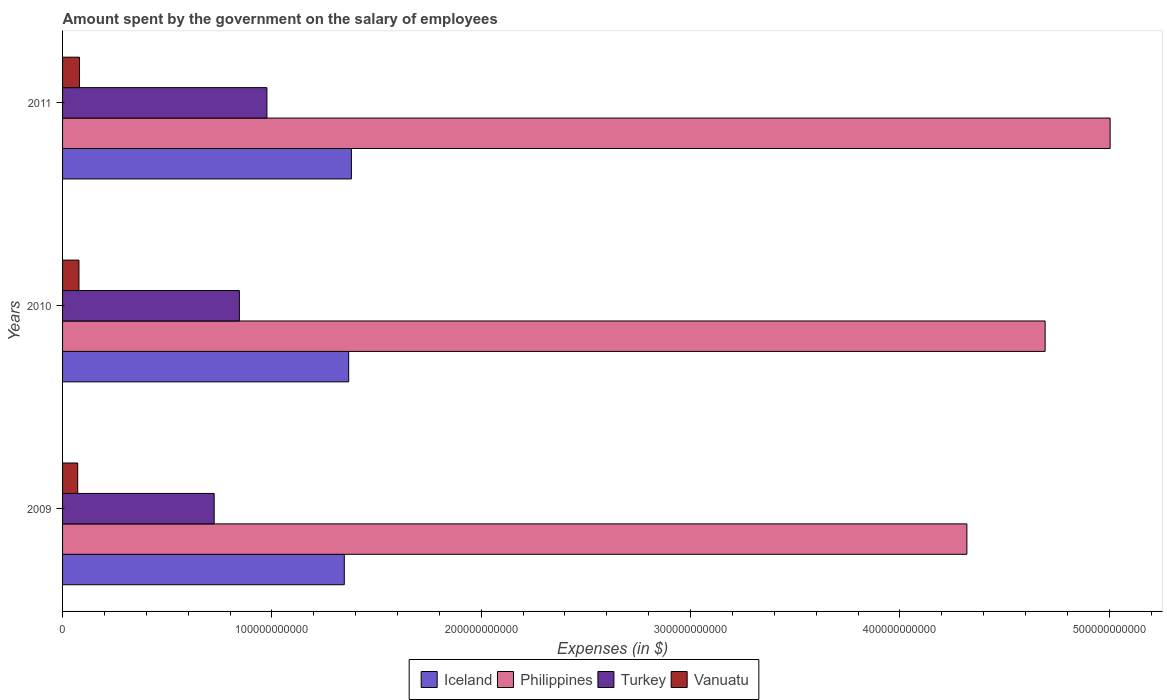How many different coloured bars are there?
Give a very brief answer. 4. Are the number of bars per tick equal to the number of legend labels?
Make the answer very short. Yes. Are the number of bars on each tick of the Y-axis equal?
Keep it short and to the point. Yes. How many bars are there on the 1st tick from the bottom?
Ensure brevity in your answer.  4. What is the amount spent on the salary of employees by the government in Turkey in 2009?
Your response must be concise. 7.24e+1. Across all years, what is the maximum amount spent on the salary of employees by the government in Vanuatu?
Offer a terse response. 8.09e+09. Across all years, what is the minimum amount spent on the salary of employees by the government in Iceland?
Ensure brevity in your answer.  1.35e+11. In which year was the amount spent on the salary of employees by the government in Vanuatu maximum?
Keep it short and to the point. 2011. In which year was the amount spent on the salary of employees by the government in Iceland minimum?
Your response must be concise. 2009. What is the total amount spent on the salary of employees by the government in Vanuatu in the graph?
Give a very brief answer. 2.32e+1. What is the difference between the amount spent on the salary of employees by the government in Turkey in 2010 and that in 2011?
Keep it short and to the point. -1.32e+1. What is the difference between the amount spent on the salary of employees by the government in Turkey in 2010 and the amount spent on the salary of employees by the government in Iceland in 2011?
Offer a terse response. -5.35e+1. What is the average amount spent on the salary of employees by the government in Iceland per year?
Keep it short and to the point. 1.36e+11. In the year 2010, what is the difference between the amount spent on the salary of employees by the government in Turkey and amount spent on the salary of employees by the government in Iceland?
Make the answer very short. -5.22e+1. What is the ratio of the amount spent on the salary of employees by the government in Turkey in 2009 to that in 2011?
Your response must be concise. 0.74. Is the amount spent on the salary of employees by the government in Turkey in 2009 less than that in 2010?
Keep it short and to the point. Yes. What is the difference between the highest and the second highest amount spent on the salary of employees by the government in Philippines?
Ensure brevity in your answer.  3.10e+1. What is the difference between the highest and the lowest amount spent on the salary of employees by the government in Iceland?
Provide a short and direct response. 3.39e+09. Is the sum of the amount spent on the salary of employees by the government in Turkey in 2009 and 2010 greater than the maximum amount spent on the salary of employees by the government in Iceland across all years?
Your answer should be compact. Yes. Is it the case that in every year, the sum of the amount spent on the salary of employees by the government in Vanuatu and amount spent on the salary of employees by the government in Turkey is greater than the sum of amount spent on the salary of employees by the government in Philippines and amount spent on the salary of employees by the government in Iceland?
Your response must be concise. No. What does the 4th bar from the bottom in 2010 represents?
Your response must be concise. Vanuatu. Is it the case that in every year, the sum of the amount spent on the salary of employees by the government in Iceland and amount spent on the salary of employees by the government in Vanuatu is greater than the amount spent on the salary of employees by the government in Turkey?
Offer a terse response. Yes. How many bars are there?
Provide a succinct answer. 12. Are all the bars in the graph horizontal?
Offer a very short reply. Yes. What is the difference between two consecutive major ticks on the X-axis?
Your answer should be very brief. 1.00e+11. Are the values on the major ticks of X-axis written in scientific E-notation?
Your answer should be compact. No. Does the graph contain any zero values?
Make the answer very short. No. Where does the legend appear in the graph?
Your answer should be compact. Bottom center. How many legend labels are there?
Your response must be concise. 4. How are the legend labels stacked?
Your answer should be very brief. Horizontal. What is the title of the graph?
Your response must be concise. Amount spent by the government on the salary of employees. Does "Namibia" appear as one of the legend labels in the graph?
Your response must be concise. No. What is the label or title of the X-axis?
Your answer should be very brief. Expenses (in $). What is the label or title of the Y-axis?
Offer a terse response. Years. What is the Expenses (in $) of Iceland in 2009?
Provide a succinct answer. 1.35e+11. What is the Expenses (in $) of Philippines in 2009?
Provide a short and direct response. 4.32e+11. What is the Expenses (in $) in Turkey in 2009?
Make the answer very short. 7.24e+1. What is the Expenses (in $) of Vanuatu in 2009?
Provide a short and direct response. 7.24e+09. What is the Expenses (in $) of Iceland in 2010?
Provide a succinct answer. 1.37e+11. What is the Expenses (in $) in Philippines in 2010?
Ensure brevity in your answer.  4.69e+11. What is the Expenses (in $) in Turkey in 2010?
Make the answer very short. 8.45e+1. What is the Expenses (in $) in Vanuatu in 2010?
Your answer should be compact. 7.83e+09. What is the Expenses (in $) of Iceland in 2011?
Provide a succinct answer. 1.38e+11. What is the Expenses (in $) of Philippines in 2011?
Provide a succinct answer. 5.00e+11. What is the Expenses (in $) in Turkey in 2011?
Provide a short and direct response. 9.76e+1. What is the Expenses (in $) of Vanuatu in 2011?
Provide a short and direct response. 8.09e+09. Across all years, what is the maximum Expenses (in $) of Iceland?
Offer a terse response. 1.38e+11. Across all years, what is the maximum Expenses (in $) of Philippines?
Provide a succinct answer. 5.00e+11. Across all years, what is the maximum Expenses (in $) of Turkey?
Ensure brevity in your answer.  9.76e+1. Across all years, what is the maximum Expenses (in $) in Vanuatu?
Your answer should be very brief. 8.09e+09. Across all years, what is the minimum Expenses (in $) in Iceland?
Provide a succinct answer. 1.35e+11. Across all years, what is the minimum Expenses (in $) of Philippines?
Your answer should be very brief. 4.32e+11. Across all years, what is the minimum Expenses (in $) of Turkey?
Ensure brevity in your answer.  7.24e+1. Across all years, what is the minimum Expenses (in $) in Vanuatu?
Your response must be concise. 7.24e+09. What is the total Expenses (in $) in Iceland in the graph?
Your response must be concise. 4.09e+11. What is the total Expenses (in $) of Philippines in the graph?
Your answer should be very brief. 1.40e+12. What is the total Expenses (in $) of Turkey in the graph?
Give a very brief answer. 2.55e+11. What is the total Expenses (in $) of Vanuatu in the graph?
Offer a very short reply. 2.32e+1. What is the difference between the Expenses (in $) of Iceland in 2009 and that in 2010?
Your answer should be very brief. -2.09e+09. What is the difference between the Expenses (in $) of Philippines in 2009 and that in 2010?
Offer a very short reply. -3.74e+1. What is the difference between the Expenses (in $) of Turkey in 2009 and that in 2010?
Your answer should be very brief. -1.20e+1. What is the difference between the Expenses (in $) in Vanuatu in 2009 and that in 2010?
Your answer should be compact. -5.95e+08. What is the difference between the Expenses (in $) in Iceland in 2009 and that in 2011?
Your response must be concise. -3.39e+09. What is the difference between the Expenses (in $) of Philippines in 2009 and that in 2011?
Your answer should be compact. -6.84e+1. What is the difference between the Expenses (in $) in Turkey in 2009 and that in 2011?
Keep it short and to the point. -2.52e+1. What is the difference between the Expenses (in $) of Vanuatu in 2009 and that in 2011?
Ensure brevity in your answer.  -8.52e+08. What is the difference between the Expenses (in $) in Iceland in 2010 and that in 2011?
Provide a short and direct response. -1.29e+09. What is the difference between the Expenses (in $) of Philippines in 2010 and that in 2011?
Your answer should be very brief. -3.10e+1. What is the difference between the Expenses (in $) of Turkey in 2010 and that in 2011?
Your answer should be very brief. -1.32e+1. What is the difference between the Expenses (in $) of Vanuatu in 2010 and that in 2011?
Provide a succinct answer. -2.57e+08. What is the difference between the Expenses (in $) in Iceland in 2009 and the Expenses (in $) in Philippines in 2010?
Offer a terse response. -3.35e+11. What is the difference between the Expenses (in $) of Iceland in 2009 and the Expenses (in $) of Turkey in 2010?
Your response must be concise. 5.01e+1. What is the difference between the Expenses (in $) of Iceland in 2009 and the Expenses (in $) of Vanuatu in 2010?
Your answer should be compact. 1.27e+11. What is the difference between the Expenses (in $) of Philippines in 2009 and the Expenses (in $) of Turkey in 2010?
Provide a short and direct response. 3.48e+11. What is the difference between the Expenses (in $) in Philippines in 2009 and the Expenses (in $) in Vanuatu in 2010?
Offer a very short reply. 4.24e+11. What is the difference between the Expenses (in $) in Turkey in 2009 and the Expenses (in $) in Vanuatu in 2010?
Provide a succinct answer. 6.46e+1. What is the difference between the Expenses (in $) in Iceland in 2009 and the Expenses (in $) in Philippines in 2011?
Offer a terse response. -3.66e+11. What is the difference between the Expenses (in $) in Iceland in 2009 and the Expenses (in $) in Turkey in 2011?
Your response must be concise. 3.70e+1. What is the difference between the Expenses (in $) in Iceland in 2009 and the Expenses (in $) in Vanuatu in 2011?
Your answer should be compact. 1.27e+11. What is the difference between the Expenses (in $) in Philippines in 2009 and the Expenses (in $) in Turkey in 2011?
Your answer should be compact. 3.34e+11. What is the difference between the Expenses (in $) of Philippines in 2009 and the Expenses (in $) of Vanuatu in 2011?
Offer a terse response. 4.24e+11. What is the difference between the Expenses (in $) of Turkey in 2009 and the Expenses (in $) of Vanuatu in 2011?
Your answer should be very brief. 6.43e+1. What is the difference between the Expenses (in $) of Iceland in 2010 and the Expenses (in $) of Philippines in 2011?
Your answer should be compact. -3.64e+11. What is the difference between the Expenses (in $) of Iceland in 2010 and the Expenses (in $) of Turkey in 2011?
Your answer should be very brief. 3.91e+1. What is the difference between the Expenses (in $) of Iceland in 2010 and the Expenses (in $) of Vanuatu in 2011?
Make the answer very short. 1.29e+11. What is the difference between the Expenses (in $) of Philippines in 2010 and the Expenses (in $) of Turkey in 2011?
Keep it short and to the point. 3.72e+11. What is the difference between the Expenses (in $) in Philippines in 2010 and the Expenses (in $) in Vanuatu in 2011?
Ensure brevity in your answer.  4.61e+11. What is the difference between the Expenses (in $) in Turkey in 2010 and the Expenses (in $) in Vanuatu in 2011?
Your response must be concise. 7.64e+1. What is the average Expenses (in $) of Iceland per year?
Your answer should be very brief. 1.36e+11. What is the average Expenses (in $) in Philippines per year?
Your answer should be compact. 4.67e+11. What is the average Expenses (in $) of Turkey per year?
Your response must be concise. 8.48e+1. What is the average Expenses (in $) of Vanuatu per year?
Give a very brief answer. 7.72e+09. In the year 2009, what is the difference between the Expenses (in $) of Iceland and Expenses (in $) of Philippines?
Your answer should be compact. -2.97e+11. In the year 2009, what is the difference between the Expenses (in $) in Iceland and Expenses (in $) in Turkey?
Make the answer very short. 6.22e+1. In the year 2009, what is the difference between the Expenses (in $) in Iceland and Expenses (in $) in Vanuatu?
Offer a terse response. 1.27e+11. In the year 2009, what is the difference between the Expenses (in $) of Philippines and Expenses (in $) of Turkey?
Your answer should be very brief. 3.60e+11. In the year 2009, what is the difference between the Expenses (in $) in Philippines and Expenses (in $) in Vanuatu?
Your answer should be compact. 4.25e+11. In the year 2009, what is the difference between the Expenses (in $) in Turkey and Expenses (in $) in Vanuatu?
Give a very brief answer. 6.52e+1. In the year 2010, what is the difference between the Expenses (in $) in Iceland and Expenses (in $) in Philippines?
Your response must be concise. -3.33e+11. In the year 2010, what is the difference between the Expenses (in $) of Iceland and Expenses (in $) of Turkey?
Offer a terse response. 5.22e+1. In the year 2010, what is the difference between the Expenses (in $) of Iceland and Expenses (in $) of Vanuatu?
Offer a terse response. 1.29e+11. In the year 2010, what is the difference between the Expenses (in $) of Philippines and Expenses (in $) of Turkey?
Offer a terse response. 3.85e+11. In the year 2010, what is the difference between the Expenses (in $) in Philippines and Expenses (in $) in Vanuatu?
Your answer should be compact. 4.62e+11. In the year 2010, what is the difference between the Expenses (in $) in Turkey and Expenses (in $) in Vanuatu?
Keep it short and to the point. 7.66e+1. In the year 2011, what is the difference between the Expenses (in $) of Iceland and Expenses (in $) of Philippines?
Give a very brief answer. -3.62e+11. In the year 2011, what is the difference between the Expenses (in $) in Iceland and Expenses (in $) in Turkey?
Your answer should be very brief. 4.04e+1. In the year 2011, what is the difference between the Expenses (in $) in Iceland and Expenses (in $) in Vanuatu?
Provide a succinct answer. 1.30e+11. In the year 2011, what is the difference between the Expenses (in $) of Philippines and Expenses (in $) of Turkey?
Your answer should be very brief. 4.03e+11. In the year 2011, what is the difference between the Expenses (in $) of Philippines and Expenses (in $) of Vanuatu?
Your response must be concise. 4.92e+11. In the year 2011, what is the difference between the Expenses (in $) of Turkey and Expenses (in $) of Vanuatu?
Make the answer very short. 8.95e+1. What is the ratio of the Expenses (in $) in Iceland in 2009 to that in 2010?
Offer a very short reply. 0.98. What is the ratio of the Expenses (in $) of Philippines in 2009 to that in 2010?
Provide a short and direct response. 0.92. What is the ratio of the Expenses (in $) in Turkey in 2009 to that in 2010?
Provide a short and direct response. 0.86. What is the ratio of the Expenses (in $) of Vanuatu in 2009 to that in 2010?
Provide a succinct answer. 0.92. What is the ratio of the Expenses (in $) of Iceland in 2009 to that in 2011?
Your response must be concise. 0.98. What is the ratio of the Expenses (in $) of Philippines in 2009 to that in 2011?
Give a very brief answer. 0.86. What is the ratio of the Expenses (in $) in Turkey in 2009 to that in 2011?
Keep it short and to the point. 0.74. What is the ratio of the Expenses (in $) in Vanuatu in 2009 to that in 2011?
Make the answer very short. 0.89. What is the ratio of the Expenses (in $) in Iceland in 2010 to that in 2011?
Your answer should be compact. 0.99. What is the ratio of the Expenses (in $) of Philippines in 2010 to that in 2011?
Your response must be concise. 0.94. What is the ratio of the Expenses (in $) in Turkey in 2010 to that in 2011?
Offer a terse response. 0.87. What is the ratio of the Expenses (in $) of Vanuatu in 2010 to that in 2011?
Make the answer very short. 0.97. What is the difference between the highest and the second highest Expenses (in $) in Iceland?
Your answer should be very brief. 1.29e+09. What is the difference between the highest and the second highest Expenses (in $) of Philippines?
Provide a short and direct response. 3.10e+1. What is the difference between the highest and the second highest Expenses (in $) in Turkey?
Your response must be concise. 1.32e+1. What is the difference between the highest and the second highest Expenses (in $) in Vanuatu?
Make the answer very short. 2.57e+08. What is the difference between the highest and the lowest Expenses (in $) in Iceland?
Your answer should be compact. 3.39e+09. What is the difference between the highest and the lowest Expenses (in $) of Philippines?
Offer a very short reply. 6.84e+1. What is the difference between the highest and the lowest Expenses (in $) in Turkey?
Make the answer very short. 2.52e+1. What is the difference between the highest and the lowest Expenses (in $) in Vanuatu?
Provide a succinct answer. 8.52e+08. 